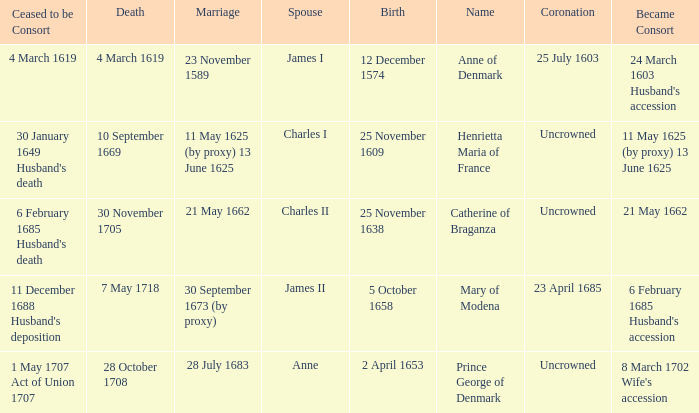When was the date of death for the person married to Charles II? 30 November 1705. 